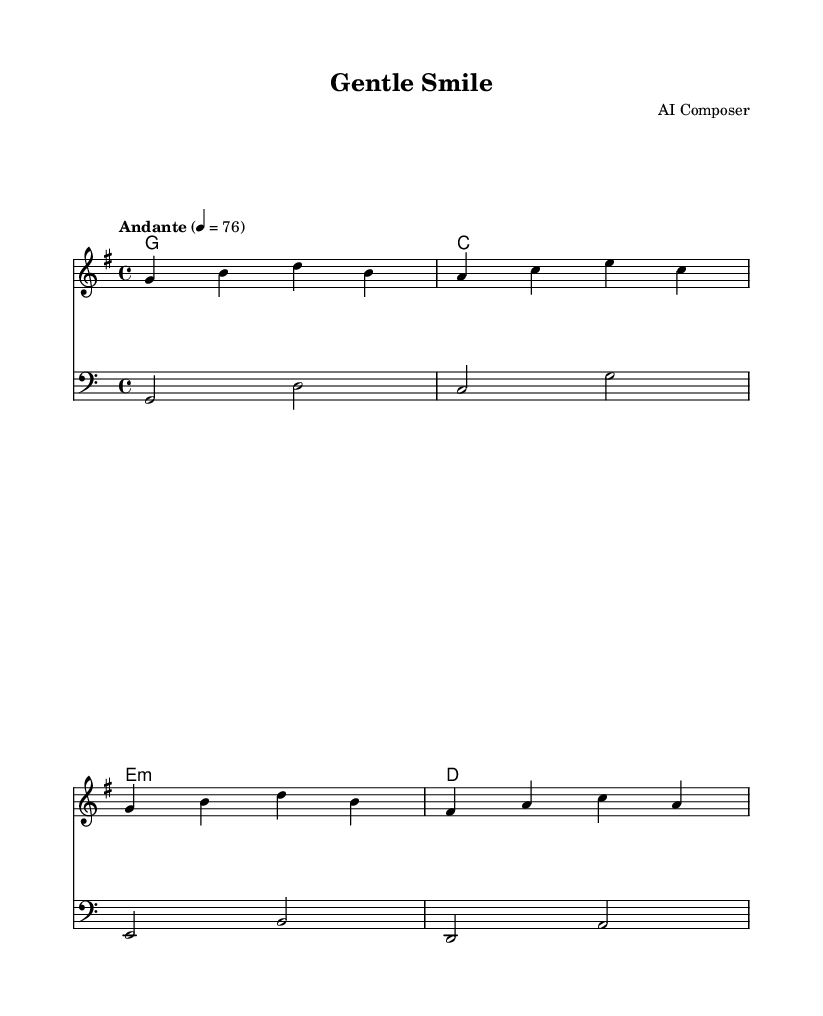What is the key signature of this music? The key signature is G major, which has one sharp (F#). You can determine this by looking at the key signature indicated at the beginning of the score, which is placed right after the clef.
Answer: G major What is the time signature of this music? The time signature is 4/4, indicated at the beginning of the score. This means there are four beats in each measure and a quarter note receives one beat.
Answer: 4/4 What is the tempo marking for this piece? The tempo marking is "Andante," which indicates a moderate pace. This is written above the staff to signify how fast the piece should be played.
Answer: Andante How many measures are present in the melody? There are four measures in the melody, which can be counted by looking at the notation and assessing where the measure lines (bar lines) are located.
Answer: 4 What are the chord qualities used in this piece? The chord qualities are G major, C major, E minor, and D major, as detailed in the chord names section of the score, which indicates the type of chords played under the melody.
Answer: G, C, E minor, D Which clef is used for the bass staff? The clef used is bass clef, which is indicated at the beginning of the lower staff, showing that this staff plays lower pitch notes.
Answer: Bass clef What is the highest note in the melody? The highest note in the melody is D, which you determine by looking at the pitch of the notes in the melody staff, where D appears as the highest pitch.
Answer: D 